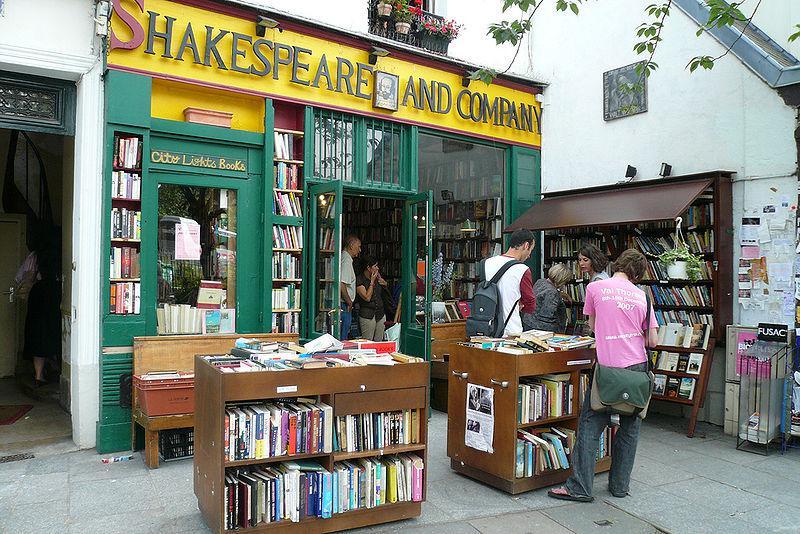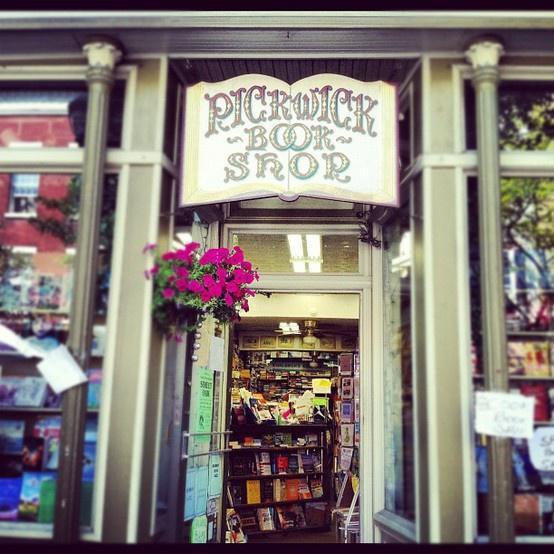The first image is the image on the left, the second image is the image on the right. Examine the images to the left and right. Is the description "In one image a bookstore with its entrance located between two large window areas has at least one advertising placard on the sidewalk in front." accurate? Answer yes or no. No. 